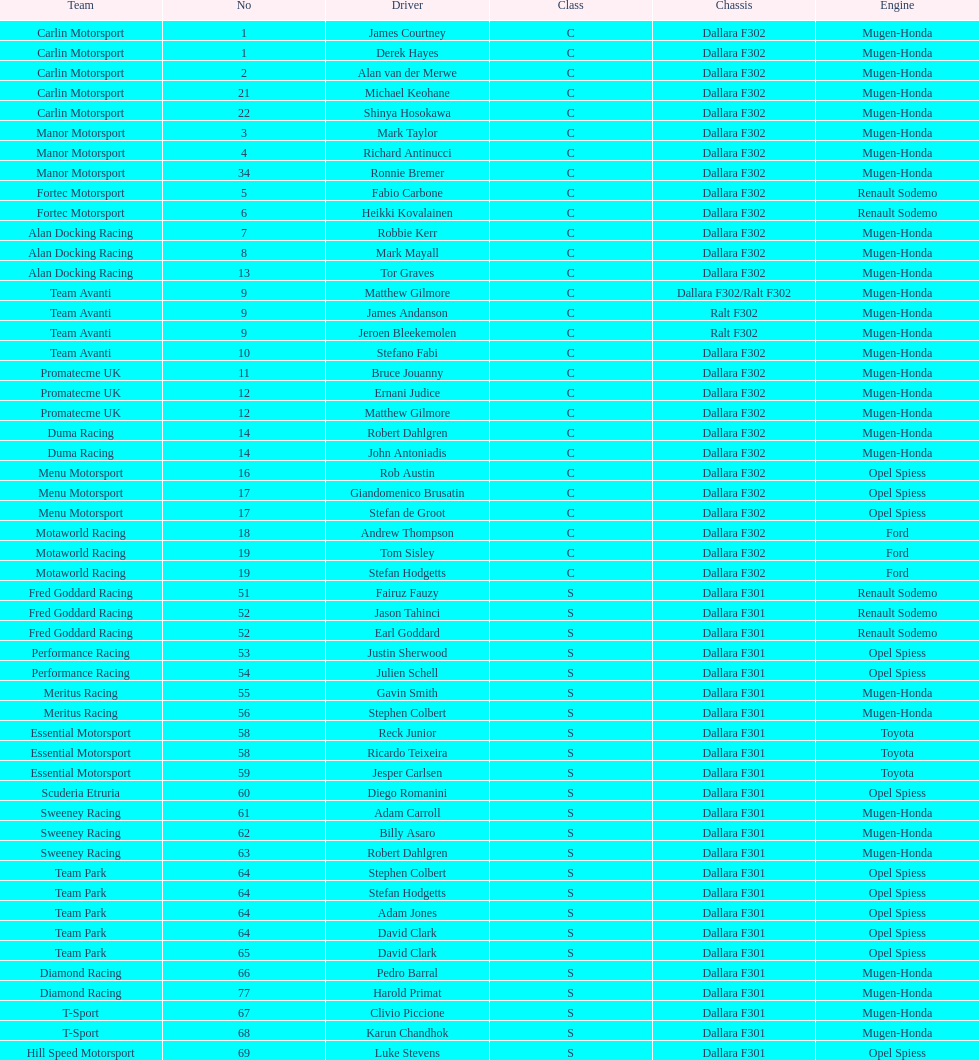What team is listed above diamond racing? Team Park. 